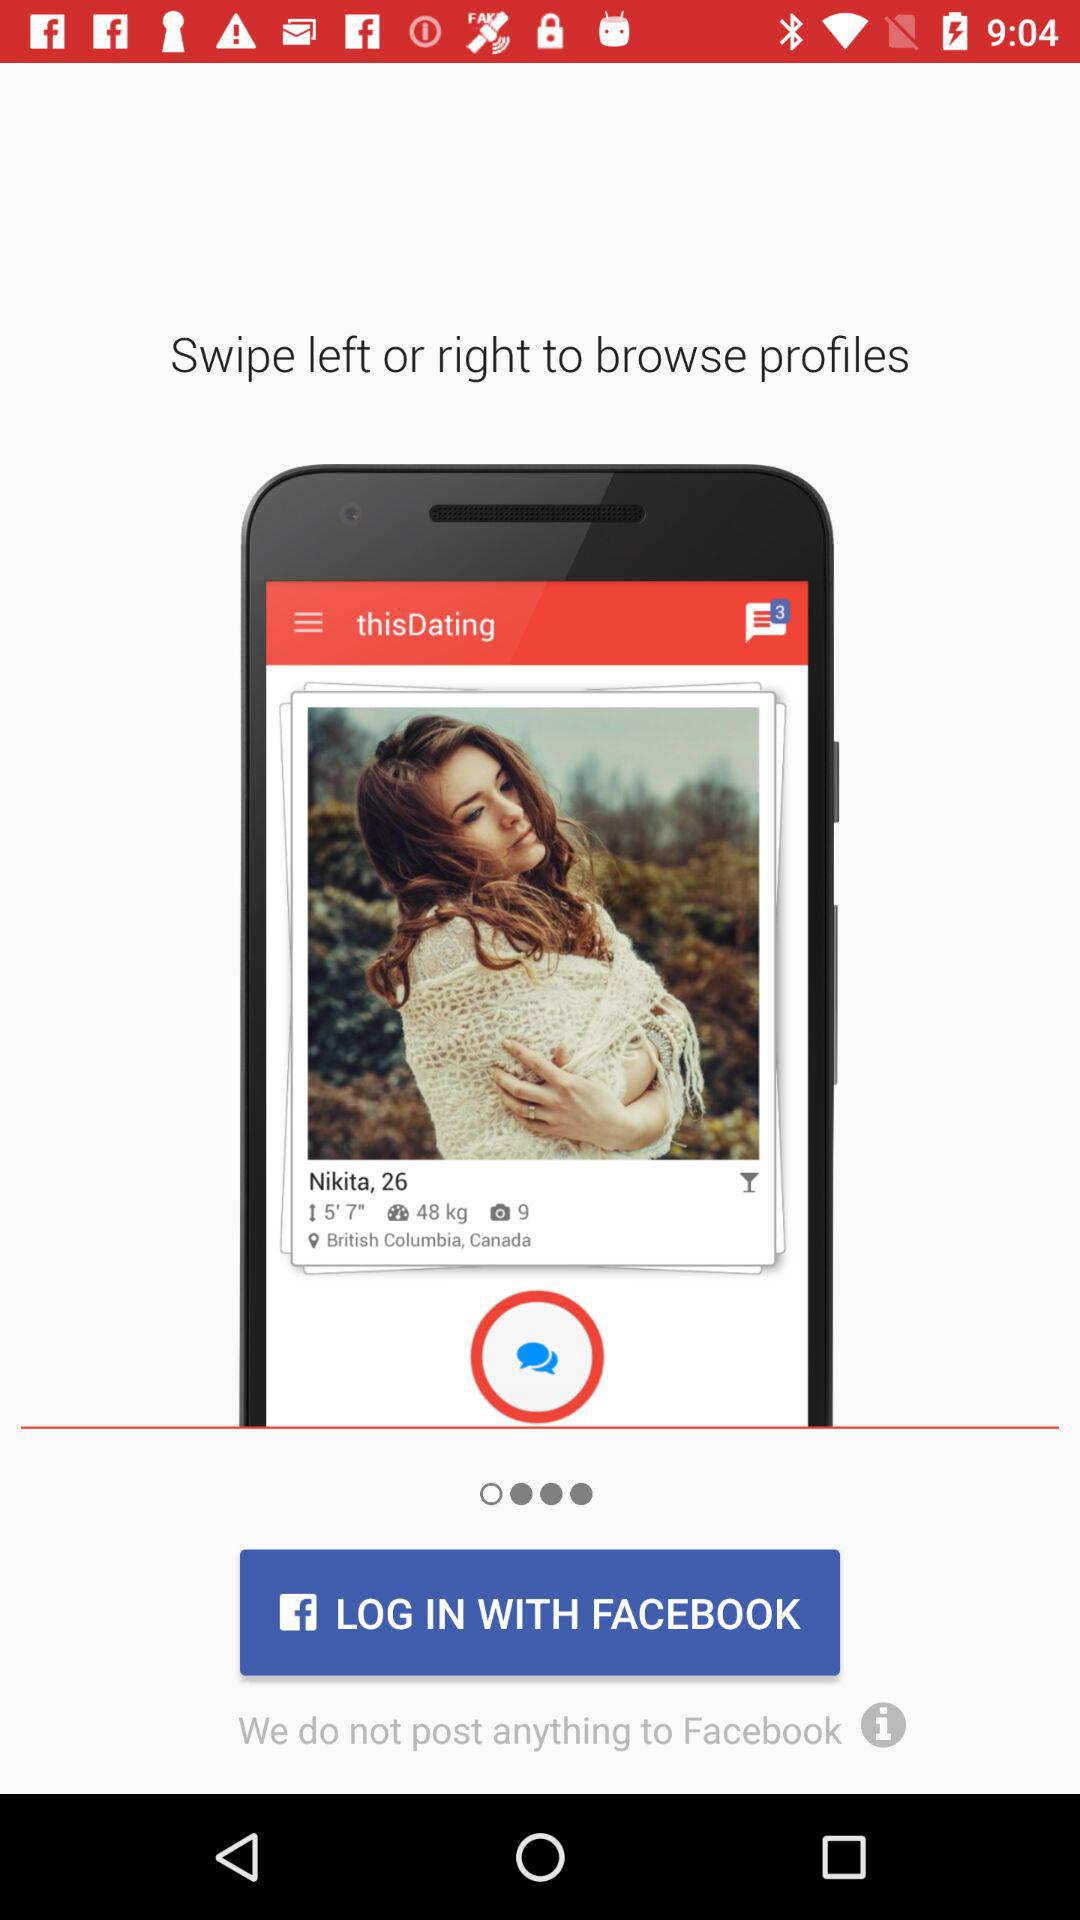Which version of the application is this?
When the provided information is insufficient, respond with <no answer>. <no answer> 